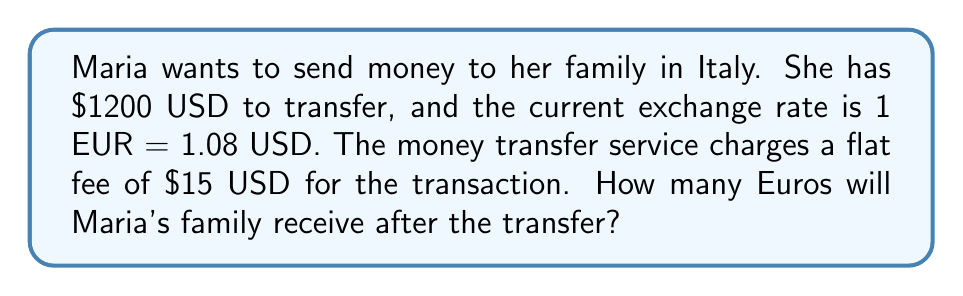Teach me how to tackle this problem. Let's approach this problem step-by-step:

1. First, we need to subtract the transfer fee from the total amount Maria wants to send:
   $1200 - $15 = $1185 USD

2. Now, we need to set up an equation to convert USD to EUR:
   Let $x$ be the amount of Euros received.
   
   $$\frac{1 \text{ EUR}}{1.08 \text{ USD}} = \frac{x \text{ EUR}}{1185 \text{ USD}}$$

3. Cross-multiply to solve for $x$:
   $$1 \cdot 1185 = 1.08x$$
   $$1185 = 1.08x$$

4. Divide both sides by 1.08:
   $$\frac{1185}{1.08} = x$$

5. Calculate the result:
   $$x \approx 1097.22 \text{ EUR}$$

6. Since we're dealing with currency, we round to the nearest cent:
   $x = 1097.22 \text{ EUR}$
Answer: Maria's family will receive 1097.22 EUR after the transfer. 